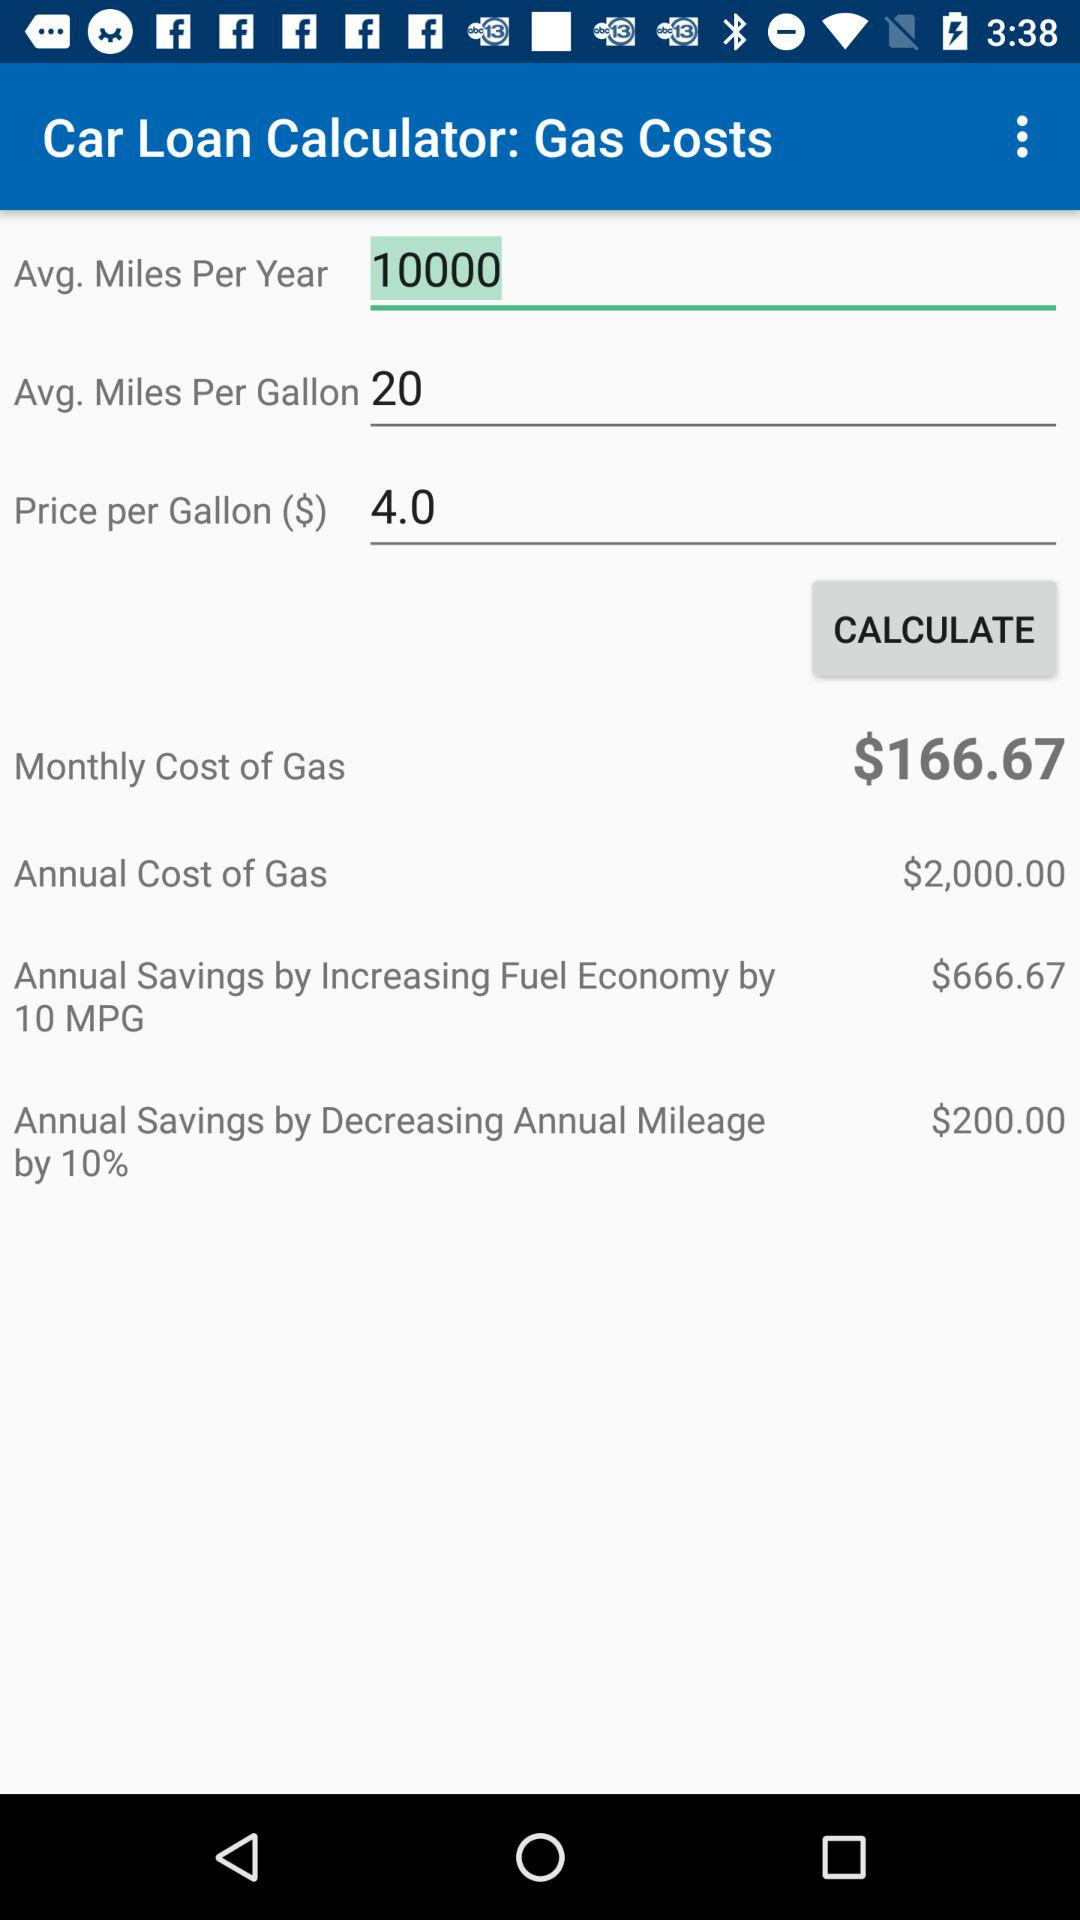If I increase my fuel economy by 10 MPG, how much will I save in a year?
Answer the question using a single word or phrase. $666.67 